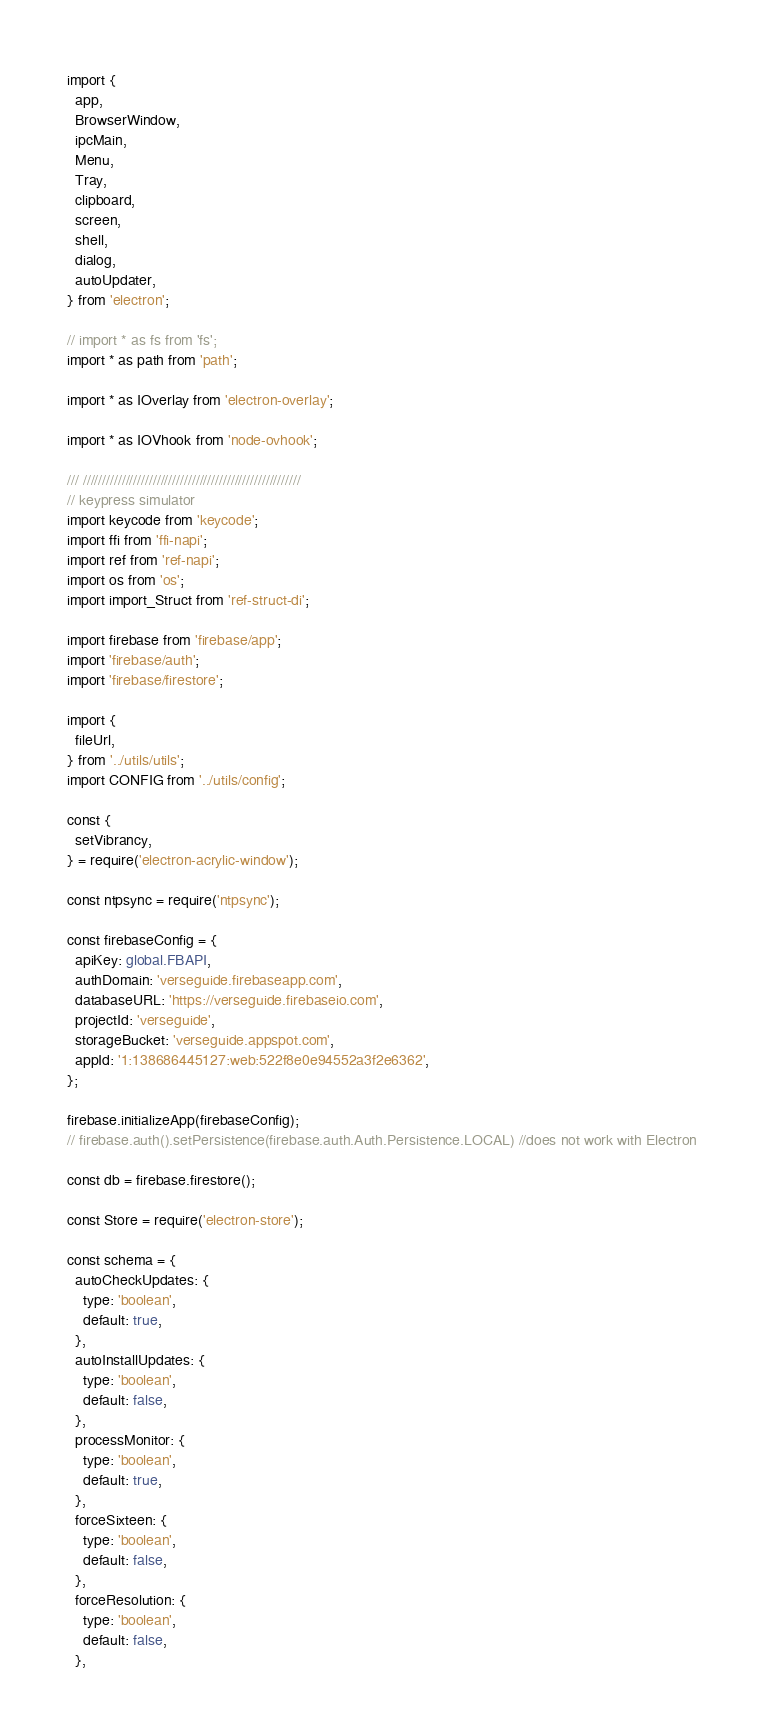Convert code to text. <code><loc_0><loc_0><loc_500><loc_500><_TypeScript_>import {
  app,
  BrowserWindow,
  ipcMain,
  Menu,
  Tray,
  clipboard,
  screen,
  shell,
  dialog,
  autoUpdater,
} from 'electron';

// import * as fs from 'fs';
import * as path from 'path';

import * as IOverlay from 'electron-overlay';

import * as IOVhook from 'node-ovhook';

/// ////////////////////////////////////////////////////////
// keypress simulator
import keycode from 'keycode';
import ffi from 'ffi-napi';
import ref from 'ref-napi';
import os from 'os';
import import_Struct from 'ref-struct-di';

import firebase from 'firebase/app';
import 'firebase/auth';
import 'firebase/firestore';

import {
  fileUrl,
} from '../utils/utils';
import CONFIG from '../utils/config';

const {
  setVibrancy,
} = require('electron-acrylic-window');

const ntpsync = require('ntpsync');

const firebaseConfig = {
  apiKey: global.FBAPI,
  authDomain: 'verseguide.firebaseapp.com',
  databaseURL: 'https://verseguide.firebaseio.com',
  projectId: 'verseguide',
  storageBucket: 'verseguide.appspot.com',
  appId: '1:138686445127:web:522f8e0e94552a3f2e6362',
};

firebase.initializeApp(firebaseConfig);
// firebase.auth().setPersistence(firebase.auth.Auth.Persistence.LOCAL) //does not work with Electron

const db = firebase.firestore();

const Store = require('electron-store');

const schema = {
  autoCheckUpdates: {
    type: 'boolean',
    default: true,
  },
  autoInstallUpdates: {
    type: 'boolean',
    default: false,
  },
  processMonitor: {
    type: 'boolean',
    default: true,
  },
  forceSixteen: {
    type: 'boolean',
    default: false,
  },
  forceResolution: {
    type: 'boolean',
    default: false,
  },</code> 